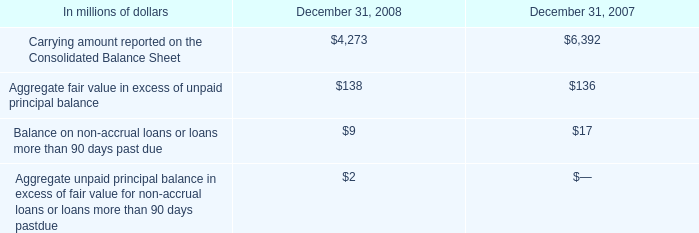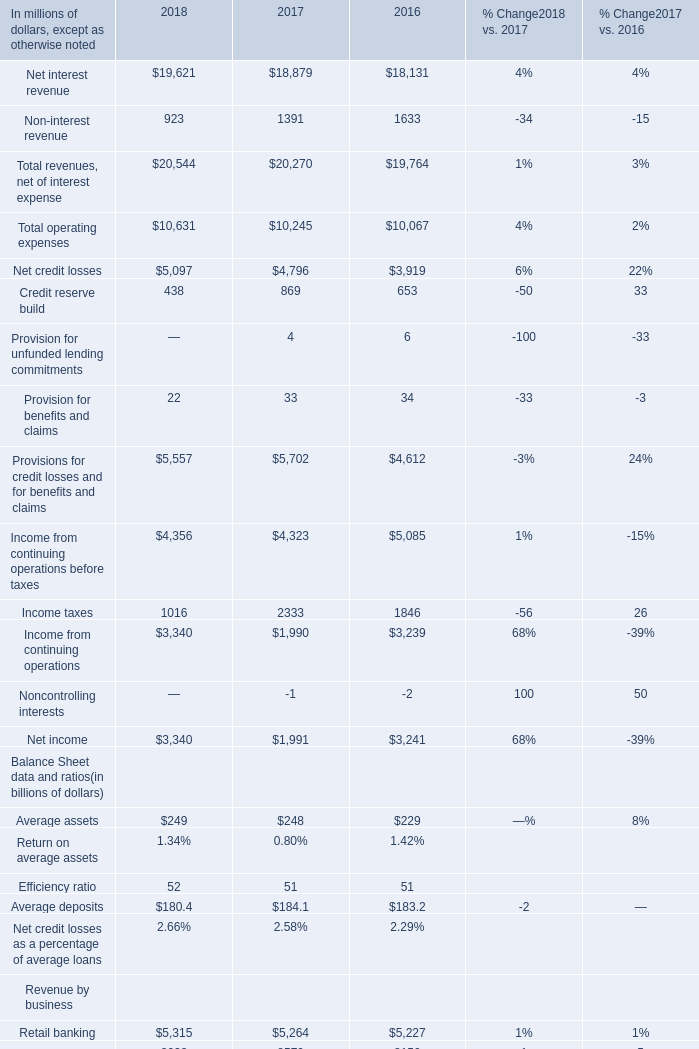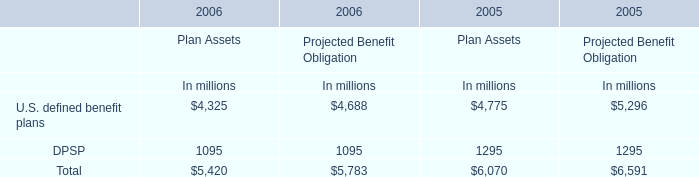What's the growth rate of Retail banking in 2018? (in million) 
Computations: ((5315 - 5264) / 5264)
Answer: 0.00969. 